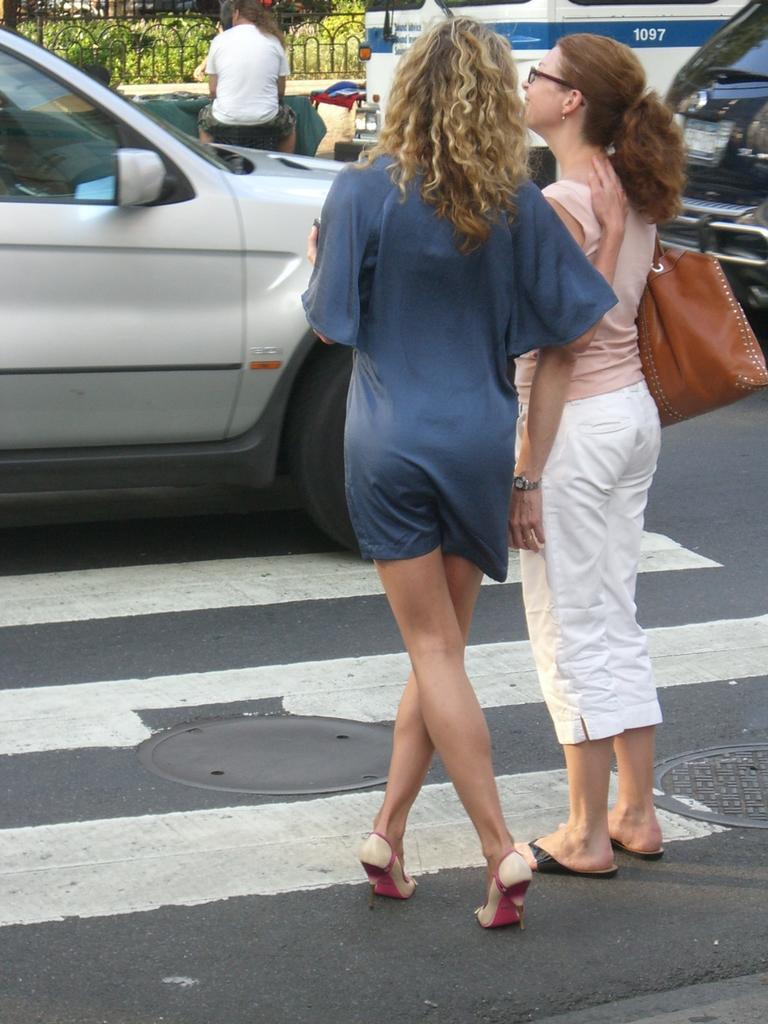Could you give a brief overview of what you see in this image? In this picture we can see vehicles and 2 women standing on the road. 